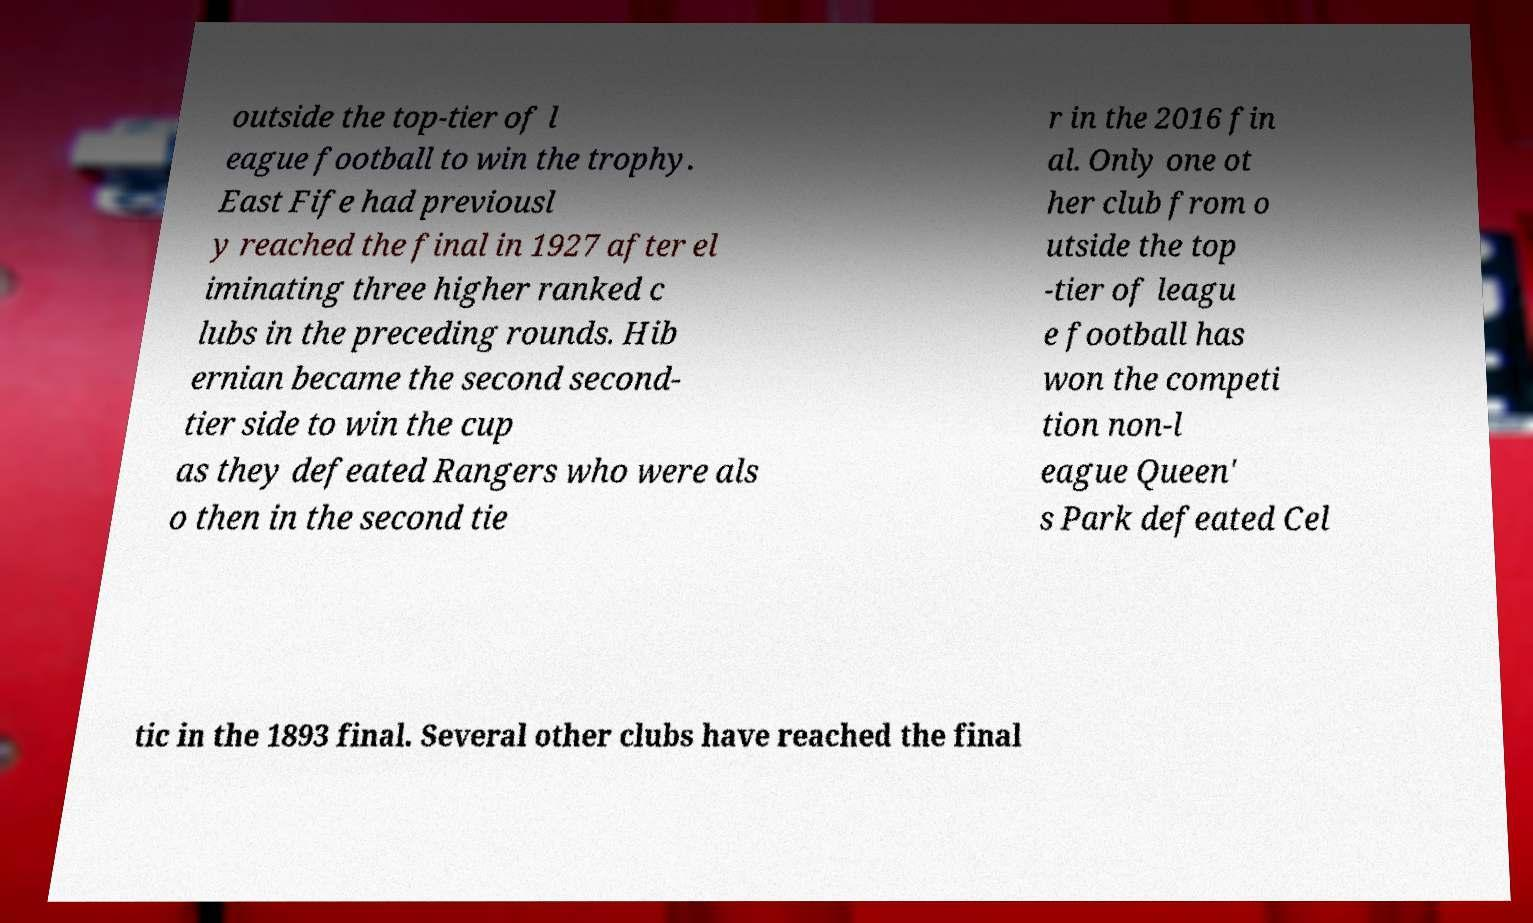Can you read and provide the text displayed in the image?This photo seems to have some interesting text. Can you extract and type it out for me? outside the top-tier of l eague football to win the trophy. East Fife had previousl y reached the final in 1927 after el iminating three higher ranked c lubs in the preceding rounds. Hib ernian became the second second- tier side to win the cup as they defeated Rangers who were als o then in the second tie r in the 2016 fin al. Only one ot her club from o utside the top -tier of leagu e football has won the competi tion non-l eague Queen' s Park defeated Cel tic in the 1893 final. Several other clubs have reached the final 